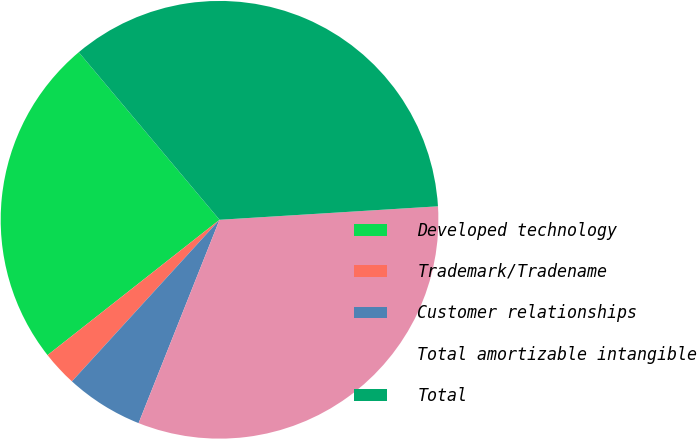<chart> <loc_0><loc_0><loc_500><loc_500><pie_chart><fcel>Developed technology<fcel>Trademark/Tradename<fcel>Customer relationships<fcel>Total amortizable intangible<fcel>Total<nl><fcel>24.49%<fcel>2.61%<fcel>5.75%<fcel>32.01%<fcel>35.14%<nl></chart> 